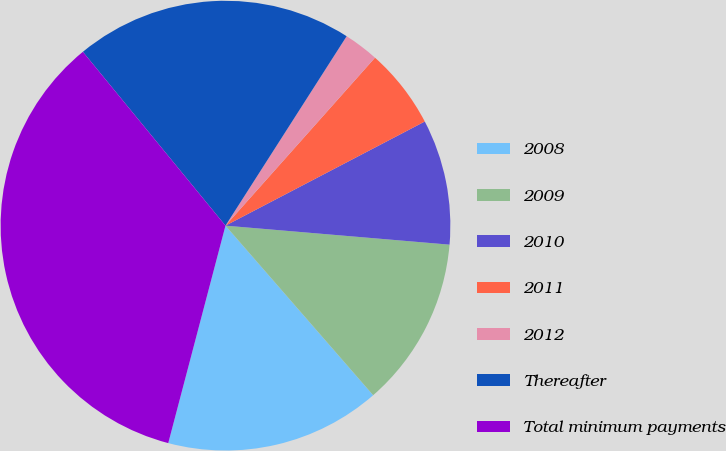Convert chart to OTSL. <chart><loc_0><loc_0><loc_500><loc_500><pie_chart><fcel>2008<fcel>2009<fcel>2010<fcel>2011<fcel>2012<fcel>Thereafter<fcel>Total minimum payments<nl><fcel>15.5%<fcel>12.25%<fcel>9.01%<fcel>5.76%<fcel>2.52%<fcel>19.99%<fcel>34.97%<nl></chart> 